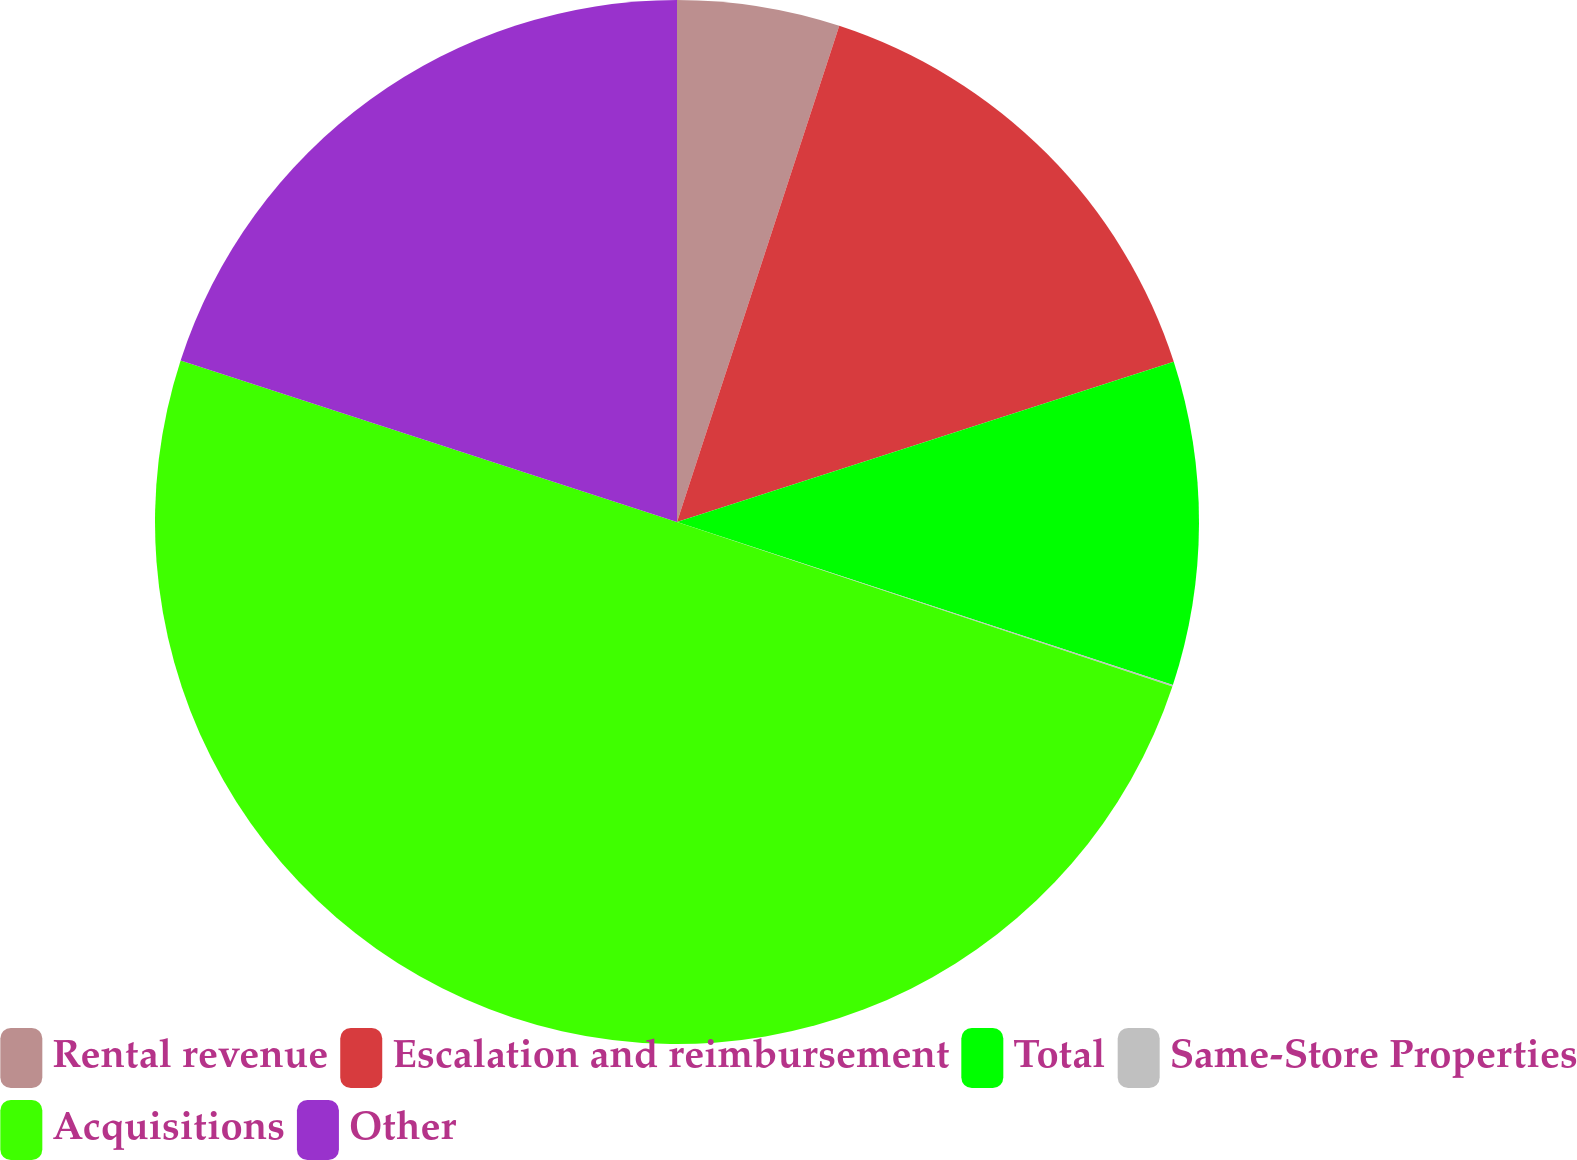Convert chart to OTSL. <chart><loc_0><loc_0><loc_500><loc_500><pie_chart><fcel>Rental revenue<fcel>Escalation and reimbursement<fcel>Total<fcel>Same-Store Properties<fcel>Acquisitions<fcel>Other<nl><fcel>5.03%<fcel>15.0%<fcel>10.02%<fcel>0.05%<fcel>49.9%<fcel>19.99%<nl></chart> 